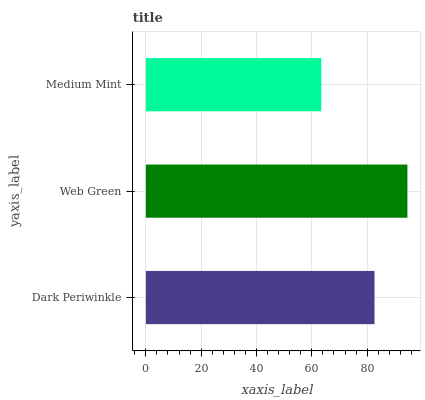Is Medium Mint the minimum?
Answer yes or no. Yes. Is Web Green the maximum?
Answer yes or no. Yes. Is Web Green the minimum?
Answer yes or no. No. Is Medium Mint the maximum?
Answer yes or no. No. Is Web Green greater than Medium Mint?
Answer yes or no. Yes. Is Medium Mint less than Web Green?
Answer yes or no. Yes. Is Medium Mint greater than Web Green?
Answer yes or no. No. Is Web Green less than Medium Mint?
Answer yes or no. No. Is Dark Periwinkle the high median?
Answer yes or no. Yes. Is Dark Periwinkle the low median?
Answer yes or no. Yes. Is Web Green the high median?
Answer yes or no. No. Is Medium Mint the low median?
Answer yes or no. No. 